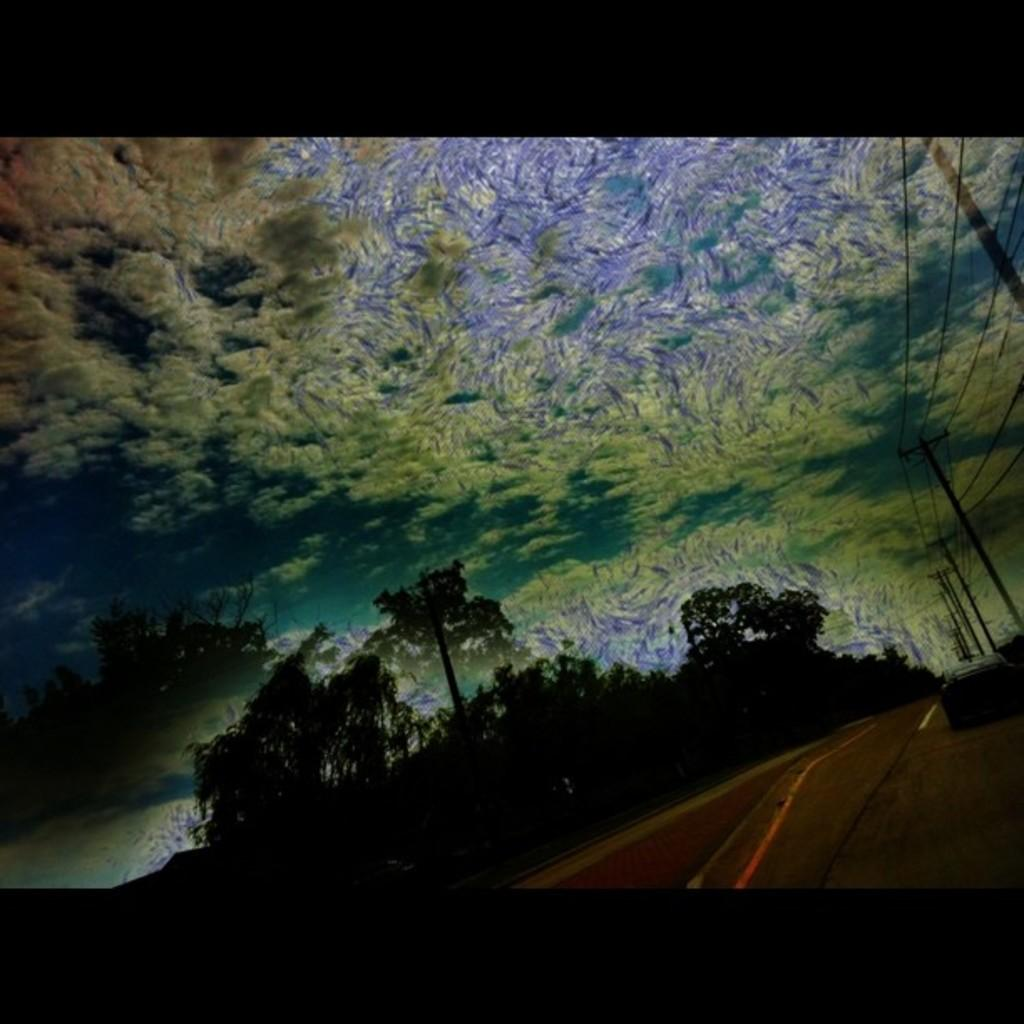What type of vegetation can be seen in the image? There are trees in the image. What type of infrastructure is present in the image? There is a road and poles visible in the image. What part of the natural environment is visible in the image? The sky is visible in the image. What type of bait is being used by the committee in the image? There is no committee or bait present in the image. What type of scissors can be seen in the image? There are no scissors present in the image. 